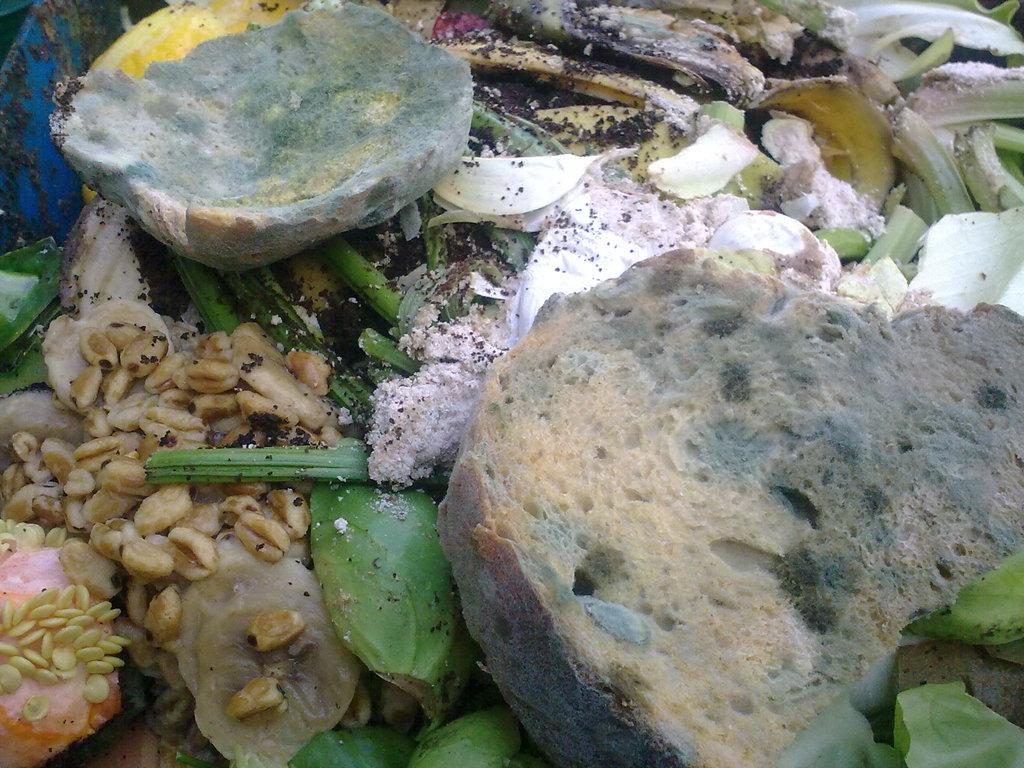Describe this image in one or two sentences. In this picture there are few garbage items. 